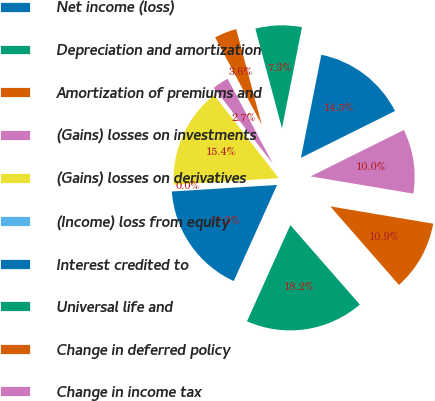Convert chart to OTSL. <chart><loc_0><loc_0><loc_500><loc_500><pie_chart><fcel>Net income (loss)<fcel>Depreciation and amortization<fcel>Amortization of premiums and<fcel>(Gains) losses on investments<fcel>(Gains) losses on derivatives<fcel>(Income) loss from equity<fcel>Interest credited to<fcel>Universal life and<fcel>Change in deferred policy<fcel>Change in income tax<nl><fcel>14.54%<fcel>7.27%<fcel>3.64%<fcel>2.73%<fcel>15.45%<fcel>0.01%<fcel>17.27%<fcel>18.18%<fcel>10.91%<fcel>10.0%<nl></chart> 